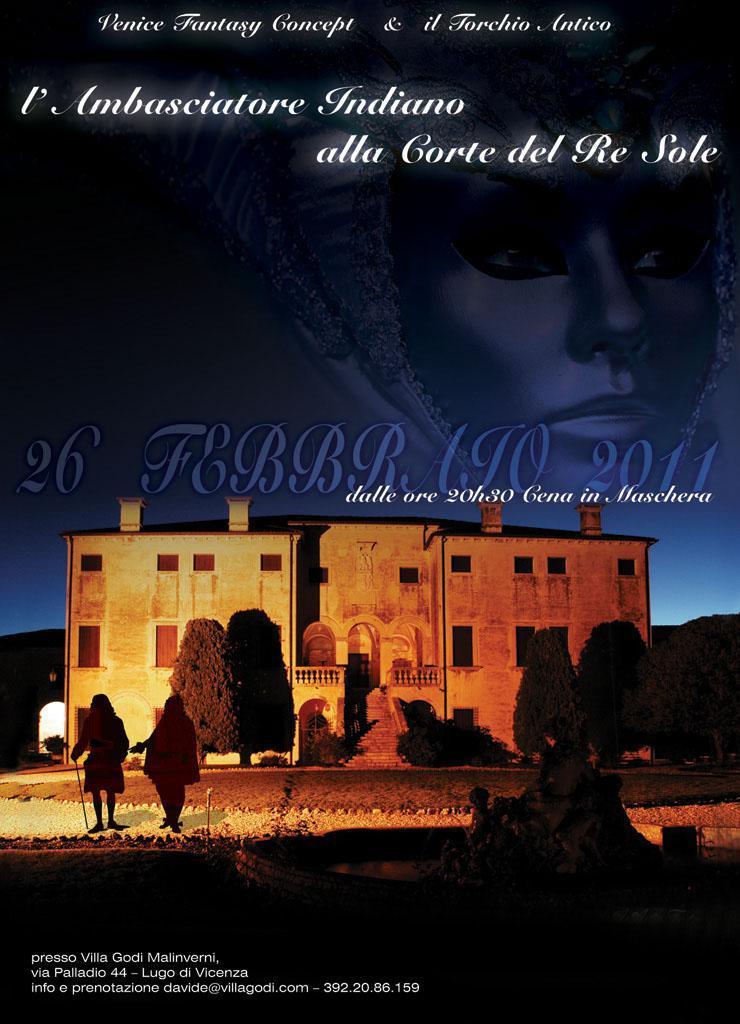In one or two sentences, can you explain what this image depicts? This is a poster having an animated image and texts. In this image, we can see there are persons, trees, a mountain, a building and the sky. 